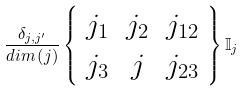Convert formula to latex. <formula><loc_0><loc_0><loc_500><loc_500>\frac { \delta _ { j , j ^ { \prime } } } { d i m \left ( j \right ) } \left \{ \begin{array} { c c c } j _ { 1 } & j _ { 2 } & j _ { 1 2 } \\ j _ { 3 } & j & j _ { 2 3 } \end{array} \right \} \mathbb { I } _ { j }</formula> 